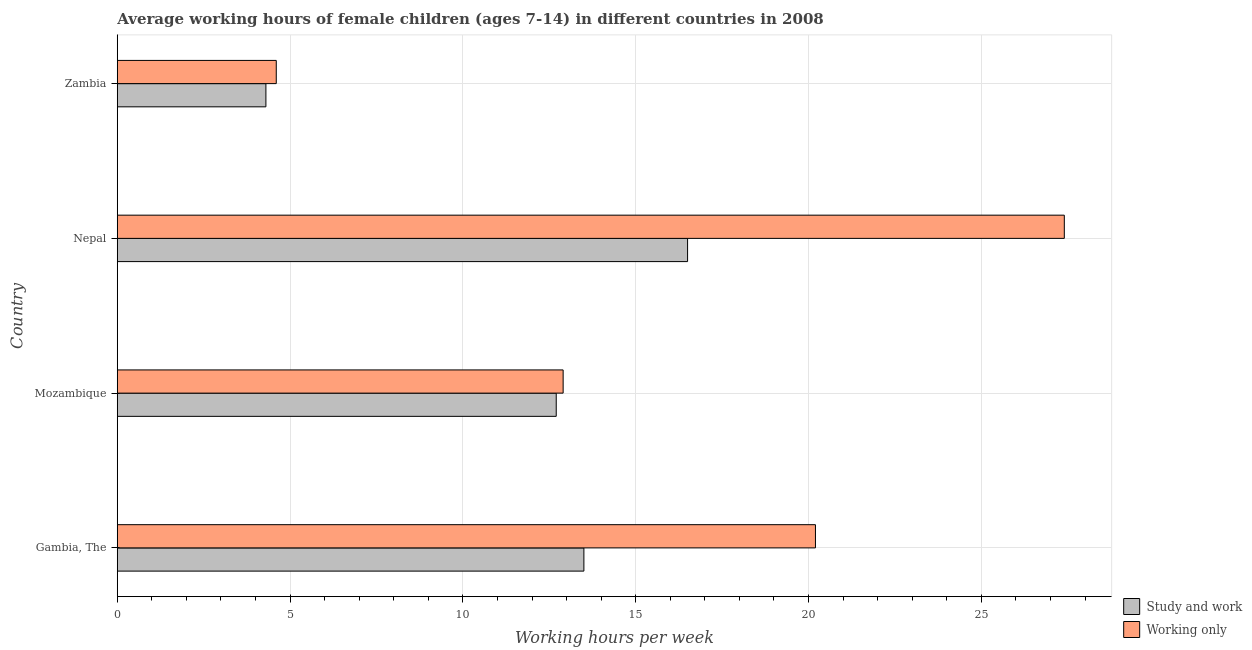How many different coloured bars are there?
Ensure brevity in your answer.  2. How many groups of bars are there?
Your answer should be compact. 4. Are the number of bars per tick equal to the number of legend labels?
Make the answer very short. Yes. Are the number of bars on each tick of the Y-axis equal?
Your answer should be very brief. Yes. How many bars are there on the 1st tick from the top?
Keep it short and to the point. 2. How many bars are there on the 3rd tick from the bottom?
Make the answer very short. 2. What is the label of the 4th group of bars from the top?
Provide a succinct answer. Gambia, The. In how many cases, is the number of bars for a given country not equal to the number of legend labels?
Provide a short and direct response. 0. Across all countries, what is the maximum average working hour of children involved in only work?
Your response must be concise. 27.4. In which country was the average working hour of children involved in study and work maximum?
Give a very brief answer. Nepal. In which country was the average working hour of children involved in only work minimum?
Provide a succinct answer. Zambia. What is the total average working hour of children involved in study and work in the graph?
Your response must be concise. 47. What is the difference between the average working hour of children involved in study and work in Gambia, The and the average working hour of children involved in only work in Nepal?
Your answer should be very brief. -13.9. What is the average average working hour of children involved in study and work per country?
Ensure brevity in your answer.  11.75. What is the difference between the average working hour of children involved in study and work and average working hour of children involved in only work in Gambia, The?
Make the answer very short. -6.7. In how many countries, is the average working hour of children involved in study and work greater than 16 hours?
Keep it short and to the point. 1. What is the ratio of the average working hour of children involved in study and work in Mozambique to that in Zambia?
Ensure brevity in your answer.  2.95. Is the difference between the average working hour of children involved in study and work in Gambia, The and Zambia greater than the difference between the average working hour of children involved in only work in Gambia, The and Zambia?
Make the answer very short. No. What is the difference between the highest and the lowest average working hour of children involved in only work?
Make the answer very short. 22.8. Is the sum of the average working hour of children involved in study and work in Gambia, The and Mozambique greater than the maximum average working hour of children involved in only work across all countries?
Make the answer very short. No. What does the 1st bar from the top in Mozambique represents?
Give a very brief answer. Working only. What does the 2nd bar from the bottom in Zambia represents?
Make the answer very short. Working only. How many countries are there in the graph?
Provide a succinct answer. 4. Are the values on the major ticks of X-axis written in scientific E-notation?
Offer a terse response. No. Does the graph contain grids?
Provide a short and direct response. Yes. What is the title of the graph?
Ensure brevity in your answer.  Average working hours of female children (ages 7-14) in different countries in 2008. What is the label or title of the X-axis?
Keep it short and to the point. Working hours per week. What is the Working hours per week of Working only in Gambia, The?
Make the answer very short. 20.2. What is the Working hours per week of Study and work in Nepal?
Offer a terse response. 16.5. What is the Working hours per week in Working only in Nepal?
Provide a short and direct response. 27.4. Across all countries, what is the maximum Working hours per week of Working only?
Offer a very short reply. 27.4. Across all countries, what is the minimum Working hours per week in Study and work?
Offer a terse response. 4.3. What is the total Working hours per week in Study and work in the graph?
Keep it short and to the point. 47. What is the total Working hours per week of Working only in the graph?
Your answer should be compact. 65.1. What is the difference between the Working hours per week of Working only in Gambia, The and that in Mozambique?
Keep it short and to the point. 7.3. What is the difference between the Working hours per week in Working only in Gambia, The and that in Nepal?
Give a very brief answer. -7.2. What is the difference between the Working hours per week in Study and work in Gambia, The and that in Zambia?
Make the answer very short. 9.2. What is the difference between the Working hours per week of Working only in Gambia, The and that in Zambia?
Give a very brief answer. 15.6. What is the difference between the Working hours per week in Working only in Nepal and that in Zambia?
Give a very brief answer. 22.8. What is the difference between the Working hours per week in Study and work in Gambia, The and the Working hours per week in Working only in Mozambique?
Give a very brief answer. 0.6. What is the difference between the Working hours per week of Study and work in Gambia, The and the Working hours per week of Working only in Nepal?
Ensure brevity in your answer.  -13.9. What is the difference between the Working hours per week in Study and work in Gambia, The and the Working hours per week in Working only in Zambia?
Keep it short and to the point. 8.9. What is the difference between the Working hours per week in Study and work in Mozambique and the Working hours per week in Working only in Nepal?
Ensure brevity in your answer.  -14.7. What is the average Working hours per week in Study and work per country?
Make the answer very short. 11.75. What is the average Working hours per week in Working only per country?
Provide a short and direct response. 16.27. What is the difference between the Working hours per week in Study and work and Working hours per week in Working only in Gambia, The?
Provide a short and direct response. -6.7. What is the difference between the Working hours per week of Study and work and Working hours per week of Working only in Mozambique?
Provide a succinct answer. -0.2. What is the difference between the Working hours per week of Study and work and Working hours per week of Working only in Nepal?
Keep it short and to the point. -10.9. What is the difference between the Working hours per week of Study and work and Working hours per week of Working only in Zambia?
Provide a succinct answer. -0.3. What is the ratio of the Working hours per week of Study and work in Gambia, The to that in Mozambique?
Provide a short and direct response. 1.06. What is the ratio of the Working hours per week in Working only in Gambia, The to that in Mozambique?
Ensure brevity in your answer.  1.57. What is the ratio of the Working hours per week of Study and work in Gambia, The to that in Nepal?
Make the answer very short. 0.82. What is the ratio of the Working hours per week of Working only in Gambia, The to that in Nepal?
Offer a very short reply. 0.74. What is the ratio of the Working hours per week of Study and work in Gambia, The to that in Zambia?
Ensure brevity in your answer.  3.14. What is the ratio of the Working hours per week in Working only in Gambia, The to that in Zambia?
Offer a very short reply. 4.39. What is the ratio of the Working hours per week in Study and work in Mozambique to that in Nepal?
Offer a very short reply. 0.77. What is the ratio of the Working hours per week in Working only in Mozambique to that in Nepal?
Provide a succinct answer. 0.47. What is the ratio of the Working hours per week of Study and work in Mozambique to that in Zambia?
Your answer should be very brief. 2.95. What is the ratio of the Working hours per week in Working only in Mozambique to that in Zambia?
Give a very brief answer. 2.8. What is the ratio of the Working hours per week of Study and work in Nepal to that in Zambia?
Offer a terse response. 3.84. What is the ratio of the Working hours per week in Working only in Nepal to that in Zambia?
Your answer should be very brief. 5.96. What is the difference between the highest and the second highest Working hours per week in Working only?
Your response must be concise. 7.2. What is the difference between the highest and the lowest Working hours per week of Study and work?
Give a very brief answer. 12.2. What is the difference between the highest and the lowest Working hours per week of Working only?
Your answer should be very brief. 22.8. 